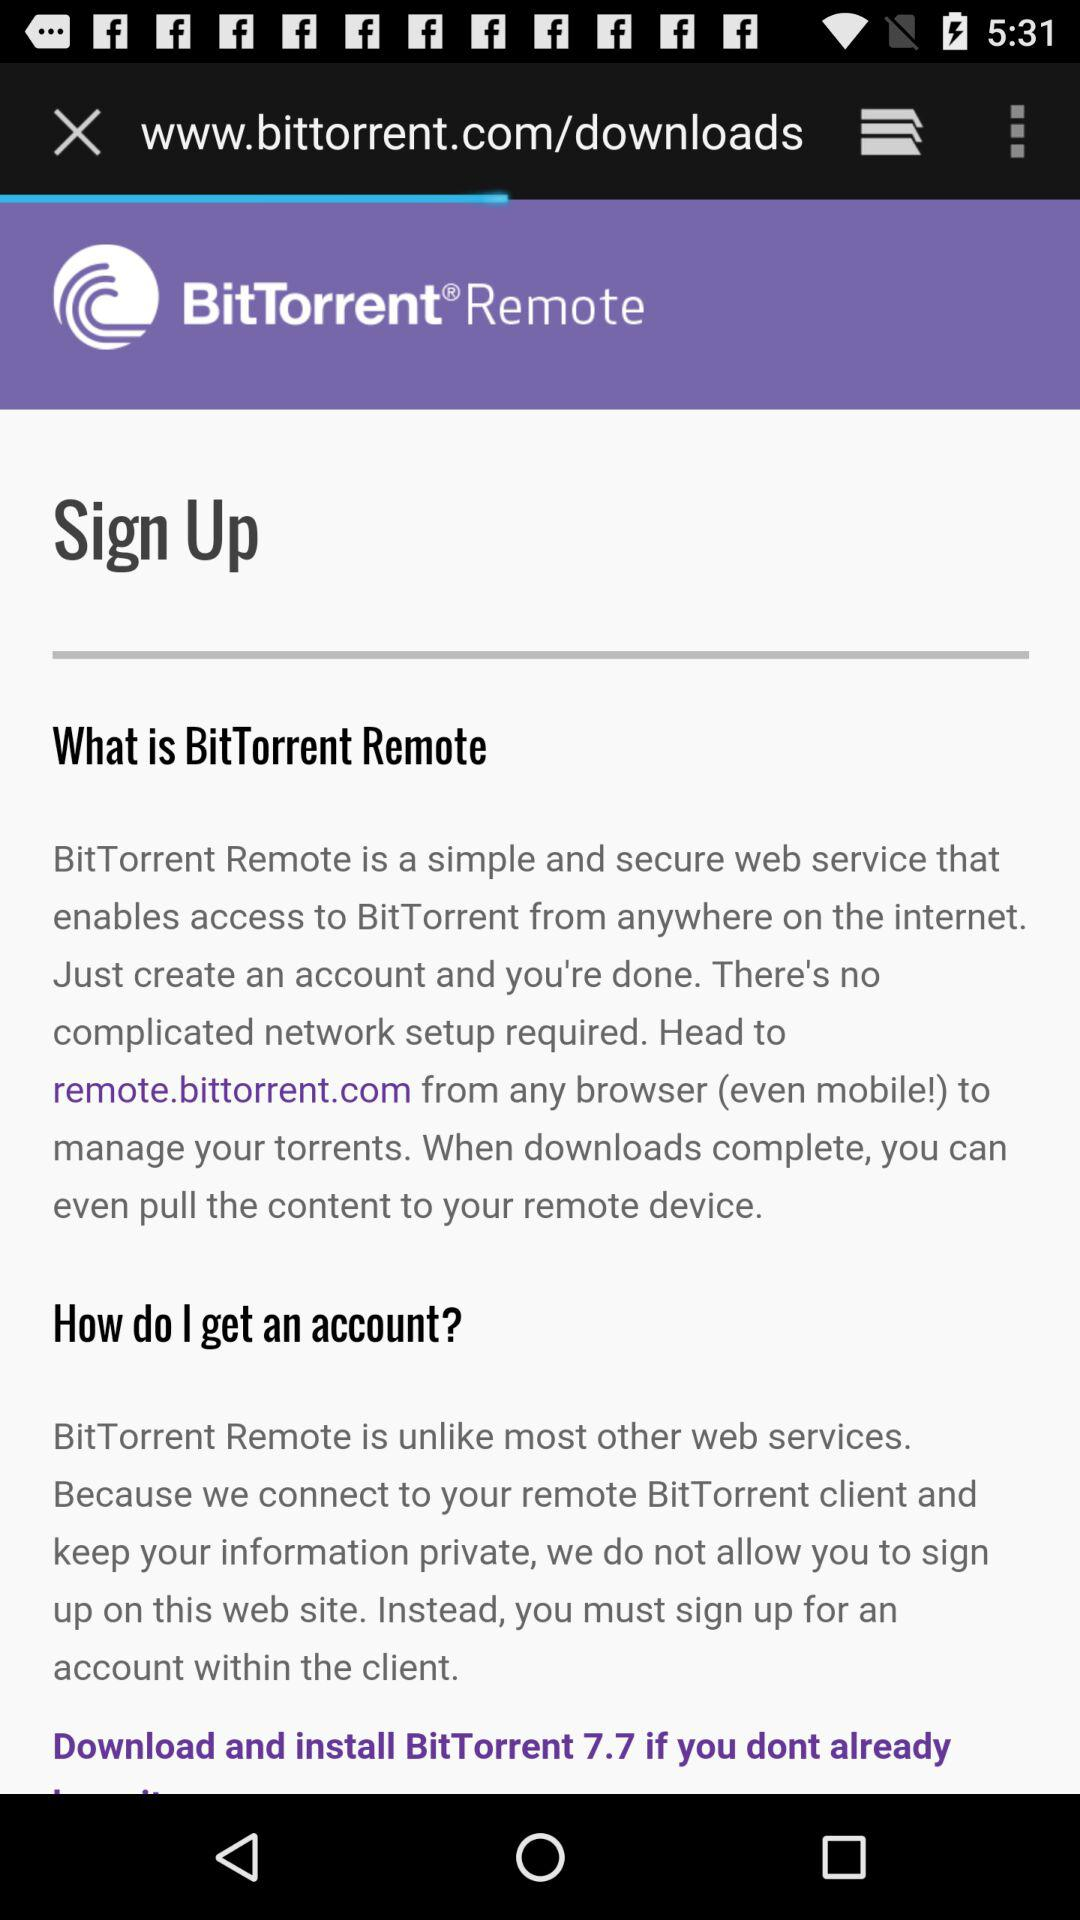What is the name of the application? The name of the application is "BitTorrent Remote". 